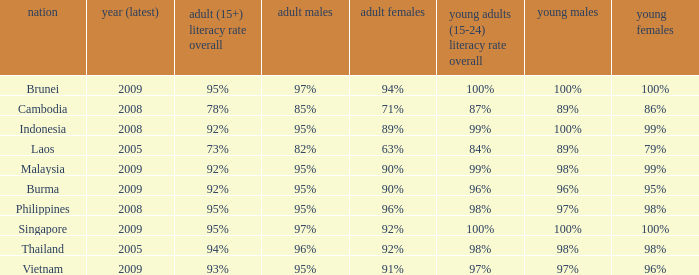What country has a Youth (15-24) Literacy Rate Total of 99%, and a Youth Men of 98%? Malaysia. 